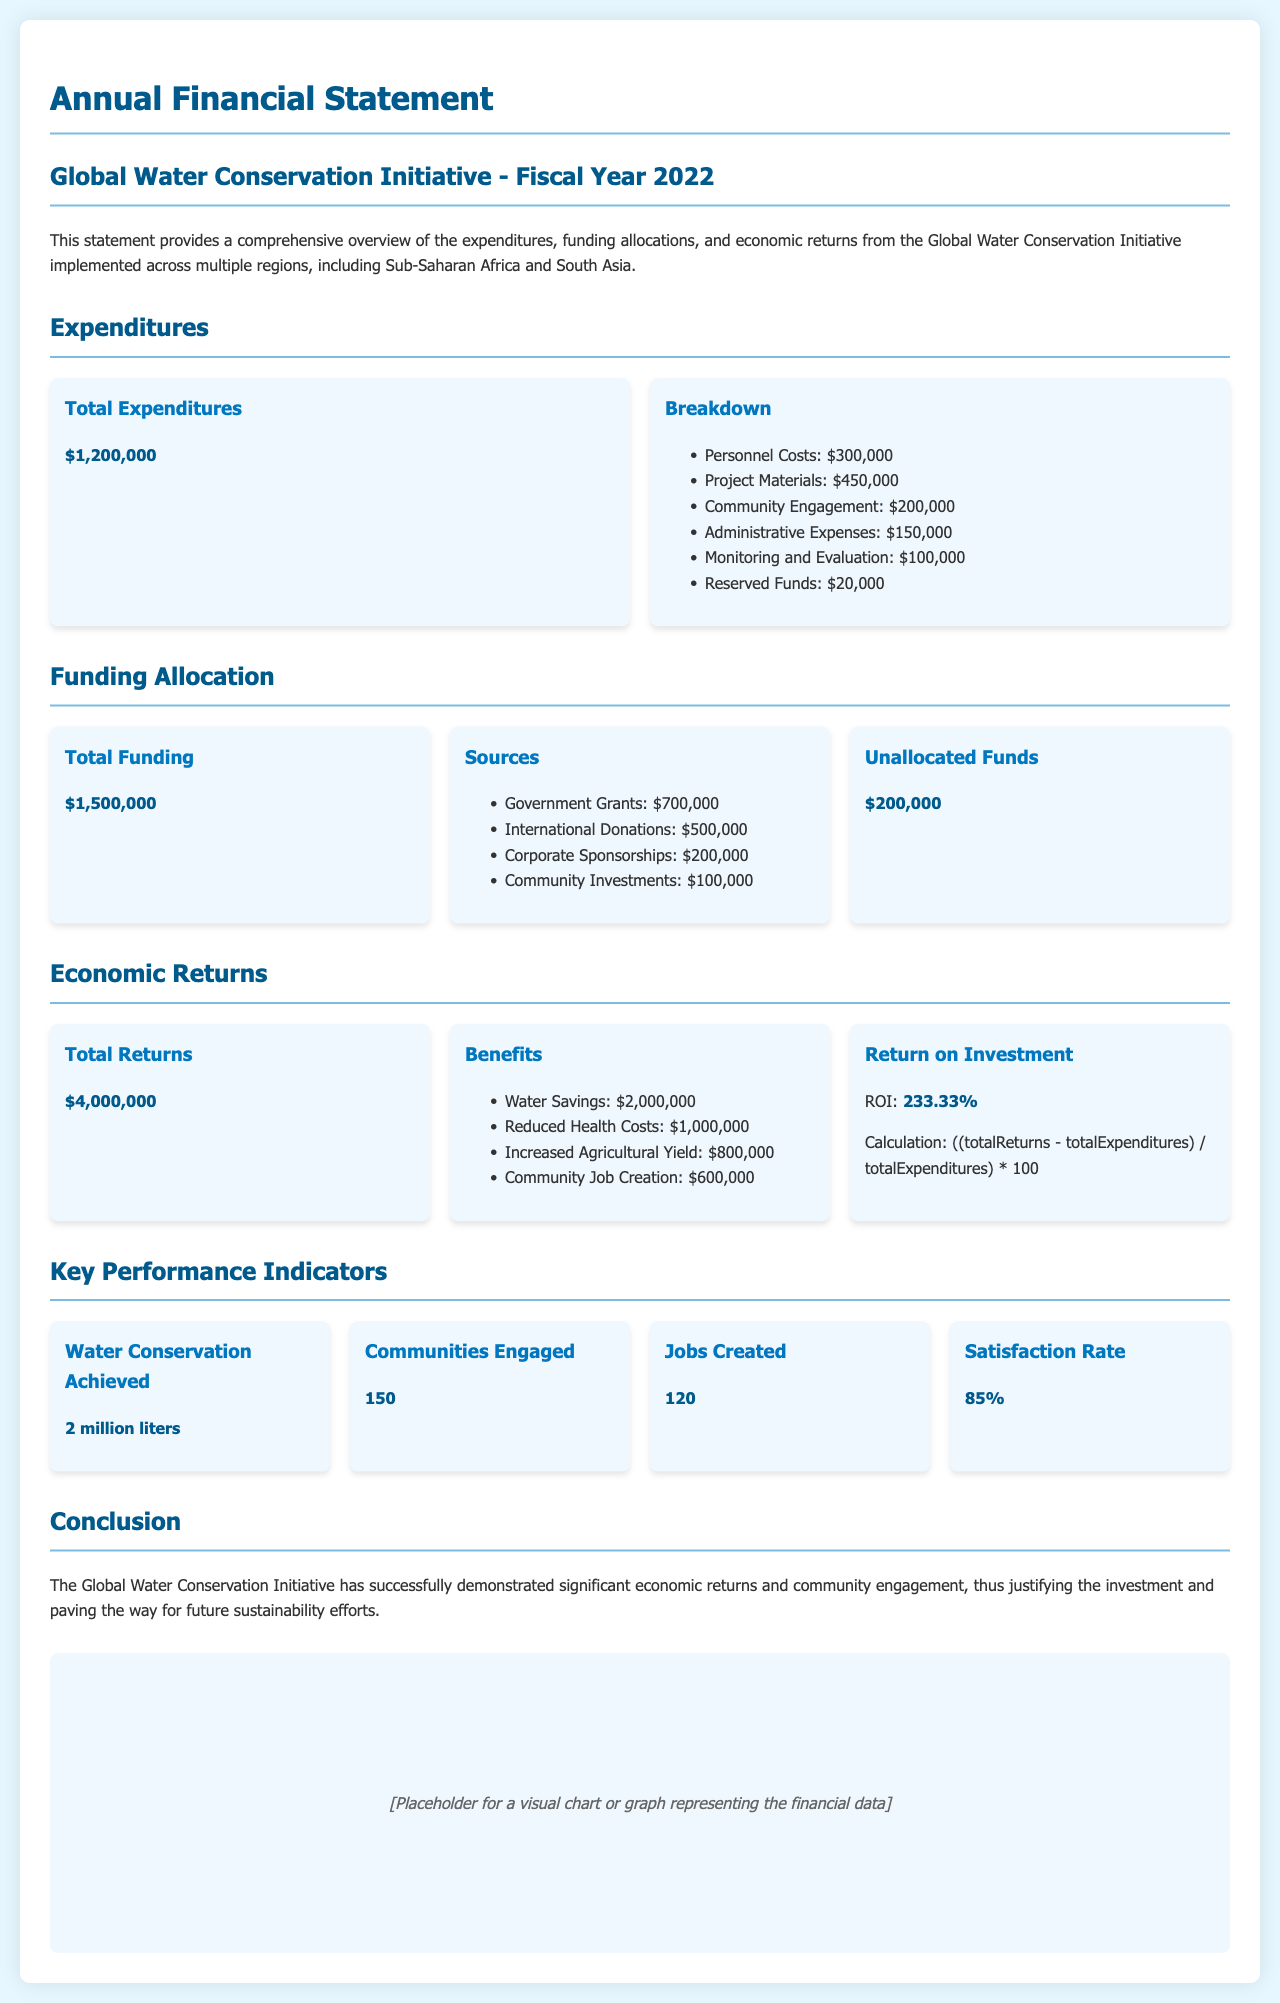what is the total expenditure? The total expenditure is listed explicitly in the document as $1,200,000.
Answer: $1,200,000 how much was spent on community engagement? The document specifies that $200,000 was allocated to community engagement.
Answer: $200,000 what is the total funding received? The total funding is clearly stated as $1,500,000 in the funding allocation section.
Answer: $1,500,000 what is the return on investment percentage? The ROI is calculated and presented as 233.33% in the economic returns section.
Answer: 233.33% how much was allocated from government grants? The document details that $700,000 came from government grants as a funding source.
Answer: $700,000 what was the total water savings achieved? The total water savings achieved is mentioned as 2 million liters in the key performance indicators section.
Answer: 2 million liters what is the satisfaction rate of the communities engaged? The satisfaction rate is listed as 85% in the key performance indicators.
Answer: 85% how many jobs were created through the initiative? The total jobs created through the project is highlighted as 120 in the document.
Answer: 120 how much was reserved in unallocated funds? The document states that $200,000 was unallocated in the funding allocation section.
Answer: $200,000 